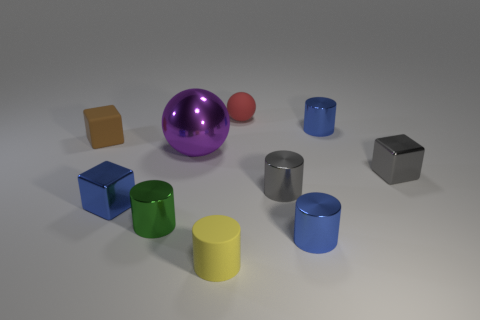The tiny matte cylinder is what color? yellow 